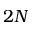<formula> <loc_0><loc_0><loc_500><loc_500>2 N</formula> 